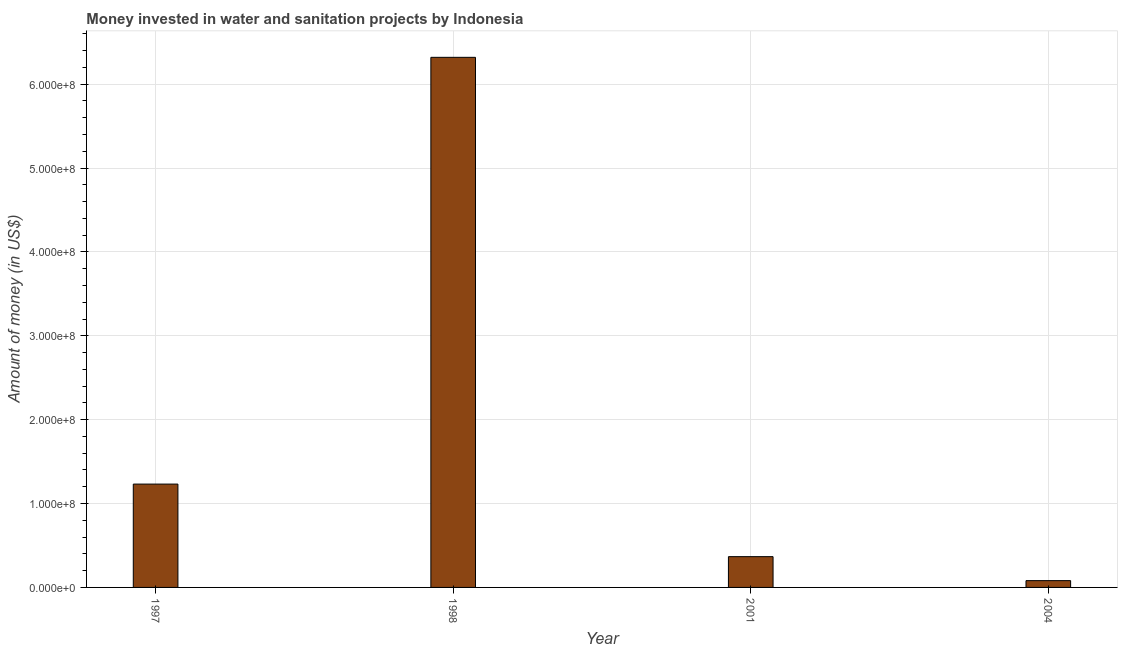Does the graph contain any zero values?
Offer a very short reply. No. What is the title of the graph?
Provide a short and direct response. Money invested in water and sanitation projects by Indonesia. What is the label or title of the X-axis?
Your answer should be very brief. Year. What is the label or title of the Y-axis?
Offer a very short reply. Amount of money (in US$). What is the investment in 2001?
Provide a short and direct response. 3.67e+07. Across all years, what is the maximum investment?
Your response must be concise. 6.32e+08. Across all years, what is the minimum investment?
Provide a short and direct response. 8.10e+06. In which year was the investment maximum?
Make the answer very short. 1998. What is the sum of the investment?
Your answer should be compact. 8.00e+08. What is the difference between the investment in 2001 and 2004?
Your answer should be very brief. 2.86e+07. What is the median investment?
Your response must be concise. 8.00e+07. In how many years, is the investment greater than 540000000 US$?
Your response must be concise. 1. What is the ratio of the investment in 1997 to that in 2004?
Offer a very short reply. 15.21. Is the investment in 2001 less than that in 2004?
Your answer should be very brief. No. What is the difference between the highest and the second highest investment?
Offer a terse response. 5.09e+08. Is the sum of the investment in 1998 and 2004 greater than the maximum investment across all years?
Offer a very short reply. Yes. What is the difference between the highest and the lowest investment?
Keep it short and to the point. 6.24e+08. In how many years, is the investment greater than the average investment taken over all years?
Your answer should be very brief. 1. How many bars are there?
Your answer should be compact. 4. Are all the bars in the graph horizontal?
Keep it short and to the point. No. How many years are there in the graph?
Ensure brevity in your answer.  4. Are the values on the major ticks of Y-axis written in scientific E-notation?
Make the answer very short. Yes. What is the Amount of money (in US$) of 1997?
Provide a succinct answer. 1.23e+08. What is the Amount of money (in US$) of 1998?
Your answer should be compact. 6.32e+08. What is the Amount of money (in US$) of 2001?
Make the answer very short. 3.67e+07. What is the Amount of money (in US$) in 2004?
Offer a very short reply. 8.10e+06. What is the difference between the Amount of money (in US$) in 1997 and 1998?
Give a very brief answer. -5.09e+08. What is the difference between the Amount of money (in US$) in 1997 and 2001?
Your answer should be compact. 8.65e+07. What is the difference between the Amount of money (in US$) in 1997 and 2004?
Provide a short and direct response. 1.15e+08. What is the difference between the Amount of money (in US$) in 1998 and 2001?
Offer a very short reply. 5.95e+08. What is the difference between the Amount of money (in US$) in 1998 and 2004?
Keep it short and to the point. 6.24e+08. What is the difference between the Amount of money (in US$) in 2001 and 2004?
Your response must be concise. 2.86e+07. What is the ratio of the Amount of money (in US$) in 1997 to that in 1998?
Offer a terse response. 0.2. What is the ratio of the Amount of money (in US$) in 1997 to that in 2001?
Make the answer very short. 3.36. What is the ratio of the Amount of money (in US$) in 1997 to that in 2004?
Ensure brevity in your answer.  15.21. What is the ratio of the Amount of money (in US$) in 1998 to that in 2001?
Give a very brief answer. 17.22. What is the ratio of the Amount of money (in US$) in 1998 to that in 2004?
Give a very brief answer. 78.03. What is the ratio of the Amount of money (in US$) in 2001 to that in 2004?
Provide a short and direct response. 4.53. 